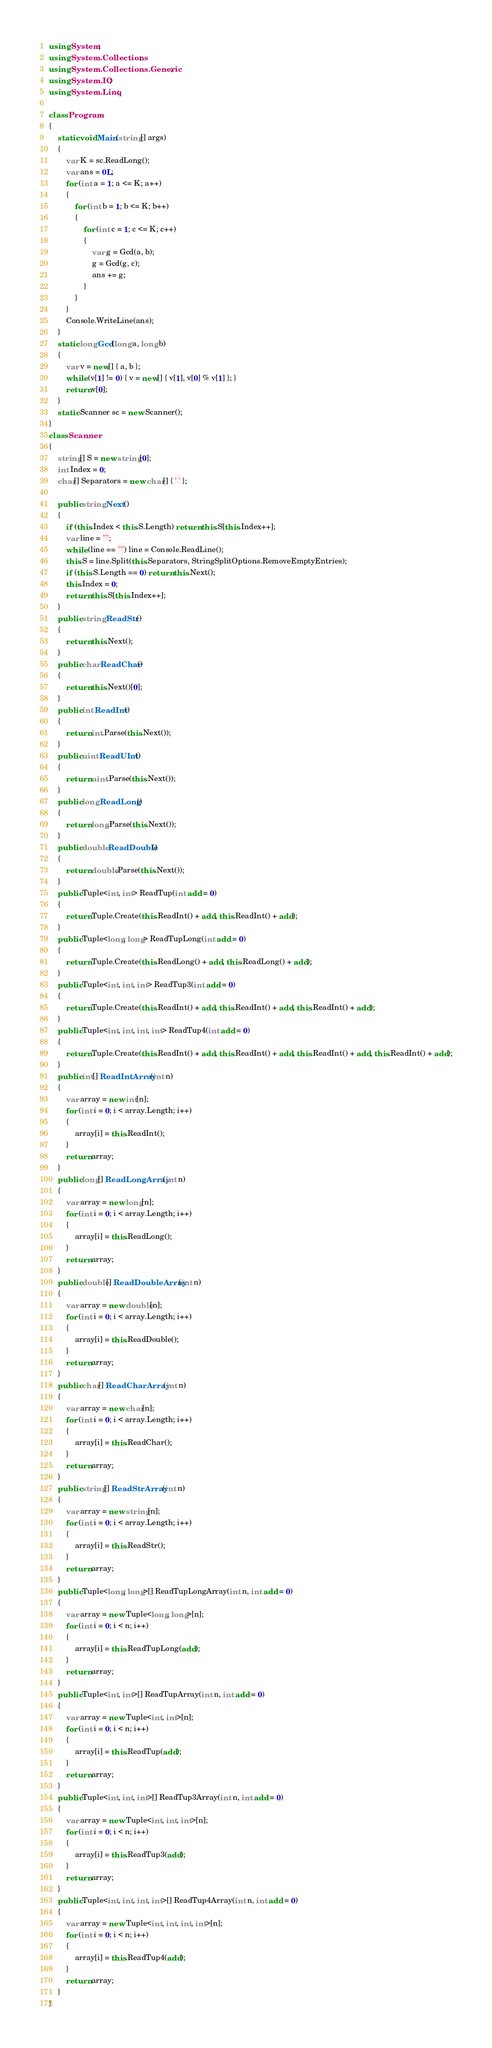<code> <loc_0><loc_0><loc_500><loc_500><_C#_>using System;
using System.Collections;
using System.Collections.Generic;
using System.IO;
using System.Linq;

class Program
{
    static void Main(string[] args)
    {
        var K = sc.ReadLong();
        var ans = 0L;
        for (int a = 1; a <= K; a++)
        {
            for (int b = 1; b <= K; b++)
            {
                for (int c = 1; c <= K; c++)
                {
                    var g = Gcd(a, b);
                    g = Gcd(g, c);
                    ans += g;
                }
            }
        }
        Console.WriteLine(ans);
    }
    static long Gcd(long a, long b)
    {
        var v = new[] { a, b };
        while (v[1] != 0) { v = new[] { v[1], v[0] % v[1] }; }
        return v[0];
    }
    static Scanner sc = new Scanner();
}
class Scanner
{
    string[] S = new string[0];
    int Index = 0;
    char[] Separators = new char[] { ' ' };

    public string Next()
    {
        if (this.Index < this.S.Length) return this.S[this.Index++];
        var line = "";
        while (line == "") line = Console.ReadLine();
        this.S = line.Split(this.Separators, StringSplitOptions.RemoveEmptyEntries);
        if (this.S.Length == 0) return this.Next();
        this.Index = 0;
        return this.S[this.Index++];
    }
    public string ReadStr()
    {
        return this.Next();
    }
    public char ReadChar()
    {
        return this.Next()[0];
    }
    public int ReadInt()
    {
        return int.Parse(this.Next());
    }
    public uint ReadUInt()
    {
        return uint.Parse(this.Next());
    }
    public long ReadLong()
    {
        return long.Parse(this.Next());
    }
    public double ReadDouble()
    {
        return double.Parse(this.Next());
    }
    public Tuple<int, int> ReadTup(int add = 0)
    {
        return Tuple.Create(this.ReadInt() + add, this.ReadInt() + add);
    }
    public Tuple<long, long> ReadTupLong(int add = 0)
    {
        return Tuple.Create(this.ReadLong() + add, this.ReadLong() + add);
    }
    public Tuple<int, int, int> ReadTup3(int add = 0)
    {
        return Tuple.Create(this.ReadInt() + add, this.ReadInt() + add, this.ReadInt() + add);
    }
    public Tuple<int, int, int, int> ReadTup4(int add = 0)
    {
        return Tuple.Create(this.ReadInt() + add, this.ReadInt() + add, this.ReadInt() + add, this.ReadInt() + add);
    }
    public int[] ReadIntArray(int n)
    {
        var array = new int[n];
        for (int i = 0; i < array.Length; i++)
        {
            array[i] = this.ReadInt();
        }
        return array;
    }
    public long[] ReadLongArray(int n)
    {
        var array = new long[n];
        for (int i = 0; i < array.Length; i++)
        {
            array[i] = this.ReadLong();
        }
        return array;
    }
    public double[] ReadDoubleArray(int n)
    {
        var array = new double[n];
        for (int i = 0; i < array.Length; i++)
        {
            array[i] = this.ReadDouble();
        }
        return array;
    }
    public char[] ReadCharArray(int n)
    {
        var array = new char[n];
        for (int i = 0; i < array.Length; i++)
        {
            array[i] = this.ReadChar();
        }
        return array;
    }
    public string[] ReadStrArray(int n)
    {
        var array = new string[n];
        for (int i = 0; i < array.Length; i++)
        {
            array[i] = this.ReadStr();
        }
        return array;
    }
    public Tuple<long, long>[] ReadTupLongArray(int n, int add = 0)
    {
        var array = new Tuple<long, long>[n];
        for (int i = 0; i < n; i++)
        {
            array[i] = this.ReadTupLong(add);
        }
        return array;
    }
    public Tuple<int, int>[] ReadTupArray(int n, int add = 0)
    {
        var array = new Tuple<int, int>[n];
        for (int i = 0; i < n; i++)
        {
            array[i] = this.ReadTup(add);
        }
        return array;
    }
    public Tuple<int, int, int>[] ReadTup3Array(int n, int add = 0)
    {
        var array = new Tuple<int, int, int>[n];
        for (int i = 0; i < n; i++)
        {
            array[i] = this.ReadTup3(add);
        }
        return array;
    }
    public Tuple<int, int, int, int>[] ReadTup4Array(int n, int add = 0)
    {
        var array = new Tuple<int, int, int, int>[n];
        for (int i = 0; i < n; i++)
        {
            array[i] = this.ReadTup4(add);
        }
        return array;
    }
}
</code> 